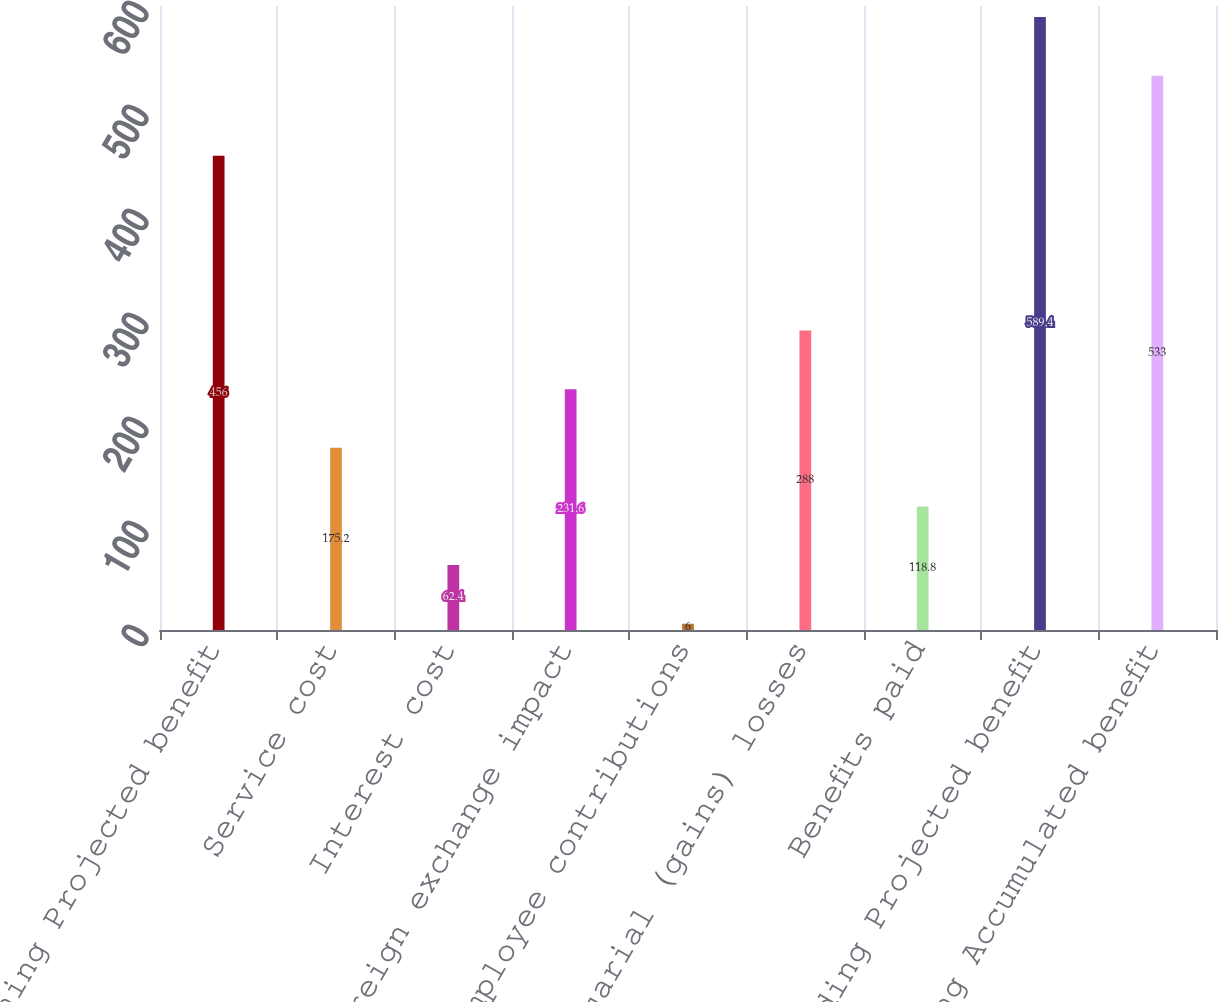Convert chart to OTSL. <chart><loc_0><loc_0><loc_500><loc_500><bar_chart><fcel>Beginning Projected benefit<fcel>Service cost<fcel>Interest cost<fcel>Foreign exchange impact<fcel>Employee contributions<fcel>Actuarial (gains) losses<fcel>Benefits paid<fcel>Ending Projected benefit<fcel>Ending Accumulated benefit<nl><fcel>456<fcel>175.2<fcel>62.4<fcel>231.6<fcel>6<fcel>288<fcel>118.8<fcel>589.4<fcel>533<nl></chart> 